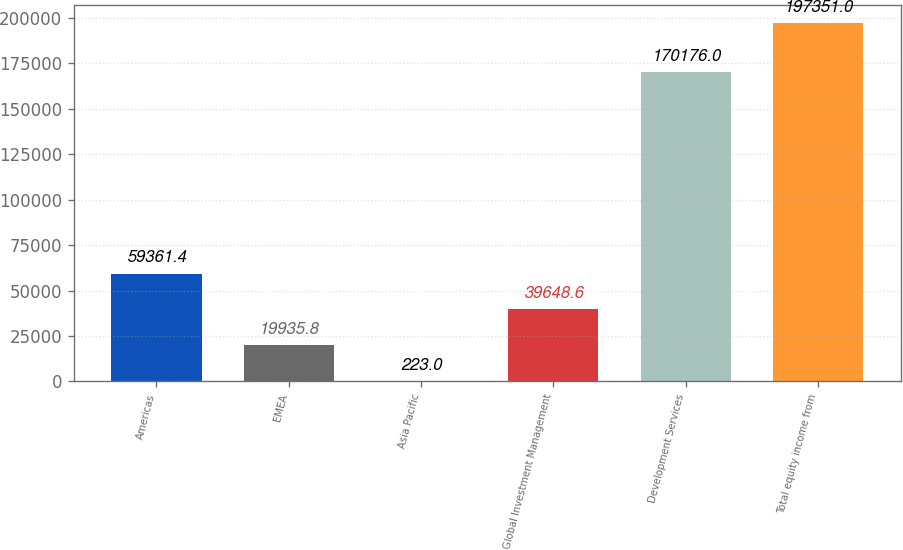Convert chart to OTSL. <chart><loc_0><loc_0><loc_500><loc_500><bar_chart><fcel>Americas<fcel>EMEA<fcel>Asia Pacific<fcel>Global Investment Management<fcel>Development Services<fcel>Total equity income from<nl><fcel>59361.4<fcel>19935.8<fcel>223<fcel>39648.6<fcel>170176<fcel>197351<nl></chart> 